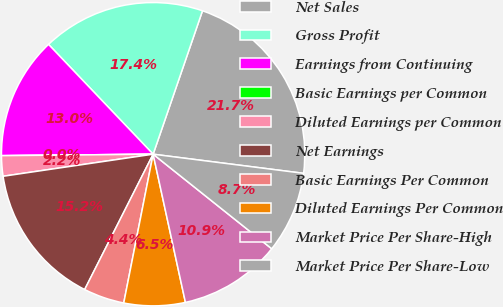Convert chart. <chart><loc_0><loc_0><loc_500><loc_500><pie_chart><fcel>Net Sales<fcel>Gross Profit<fcel>Earnings from Continuing<fcel>Basic Earnings per Common<fcel>Diluted Earnings per Common<fcel>Net Earnings<fcel>Basic Earnings Per Common<fcel>Diluted Earnings Per Common<fcel>Market Price Per Share-High<fcel>Market Price Per Share-Low<nl><fcel>21.74%<fcel>17.39%<fcel>13.04%<fcel>0.0%<fcel>2.17%<fcel>15.22%<fcel>4.35%<fcel>6.52%<fcel>10.87%<fcel>8.7%<nl></chart> 